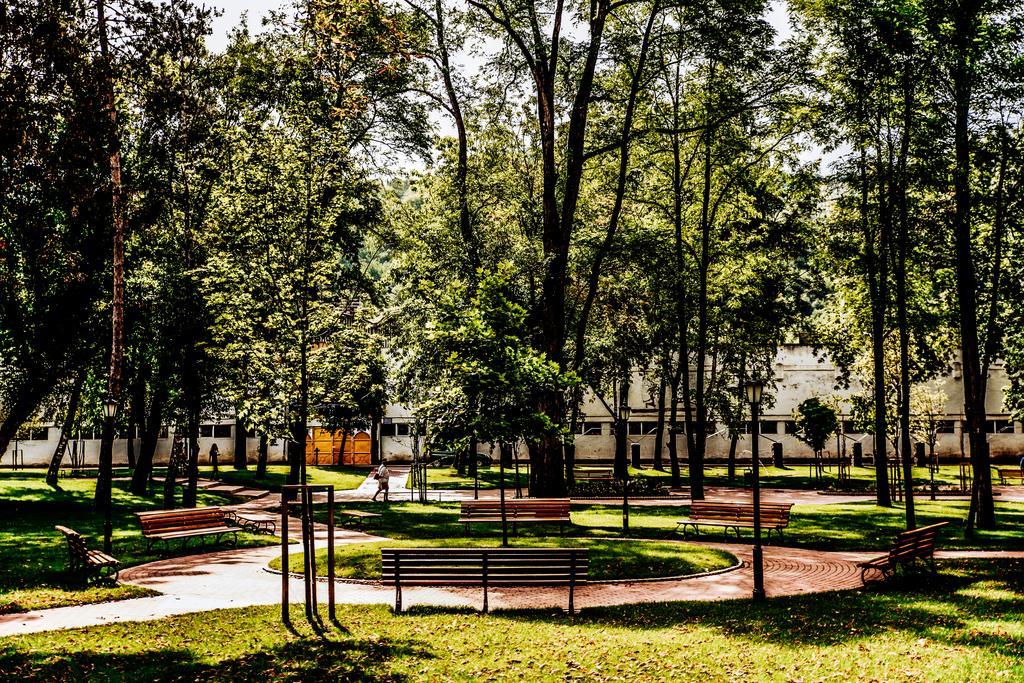Could you give a brief overview of what you see in this image? In this image there is a building in the background. In front of the building it looks like is a park where there are so many trees. In the middle there are benches in the circular manner. At the bottom there is ground on which there is grass. 